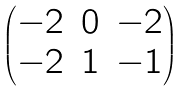<formula> <loc_0><loc_0><loc_500><loc_500>\begin{pmatrix} - 2 & 0 & - 2 \\ - 2 & 1 & - 1 \end{pmatrix}</formula> 